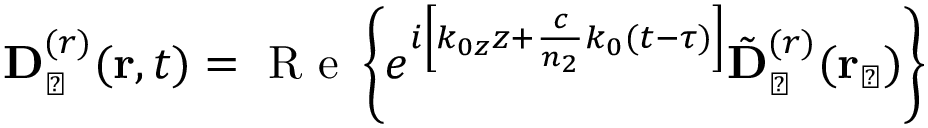<formula> <loc_0><loc_0><loc_500><loc_500>{ D } _ { \perp } ^ { ( r ) } ( { r } , t ) = R e \left \{ e ^ { i \left [ k _ { 0 z } z + \frac { c } { n _ { 2 } } k _ { 0 } ( t - \tau ) \right ] } { \tilde { D } } _ { \perp } ^ { ( r ) } ( { r } _ { \perp } ) \right \}</formula> 